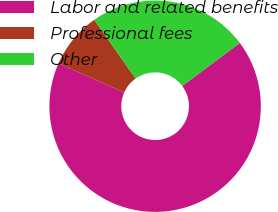<chart> <loc_0><loc_0><loc_500><loc_500><pie_chart><fcel>Labor and related benefits<fcel>Professional fees<fcel>Other<nl><fcel>66.87%<fcel>8.57%<fcel>24.56%<nl></chart> 